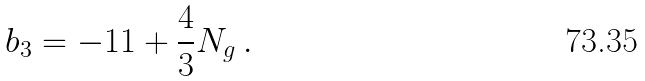Convert formula to latex. <formula><loc_0><loc_0><loc_500><loc_500>b _ { 3 } = - 1 1 + \frac { 4 } { 3 } N _ { g } \, .</formula> 